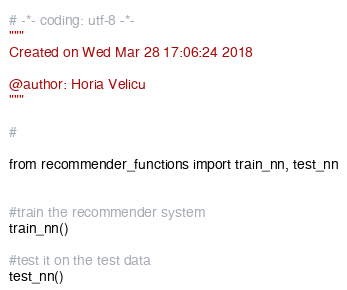<code> <loc_0><loc_0><loc_500><loc_500><_Python_># -*- coding: utf-8 -*-
"""
Created on Wed Mar 28 17:06:24 2018

@author: Horia Velicu
"""

#

from recommender_functions import train_nn, test_nn


#train the recommender system
train_nn()

#test it on the test data
test_nn()

</code> 